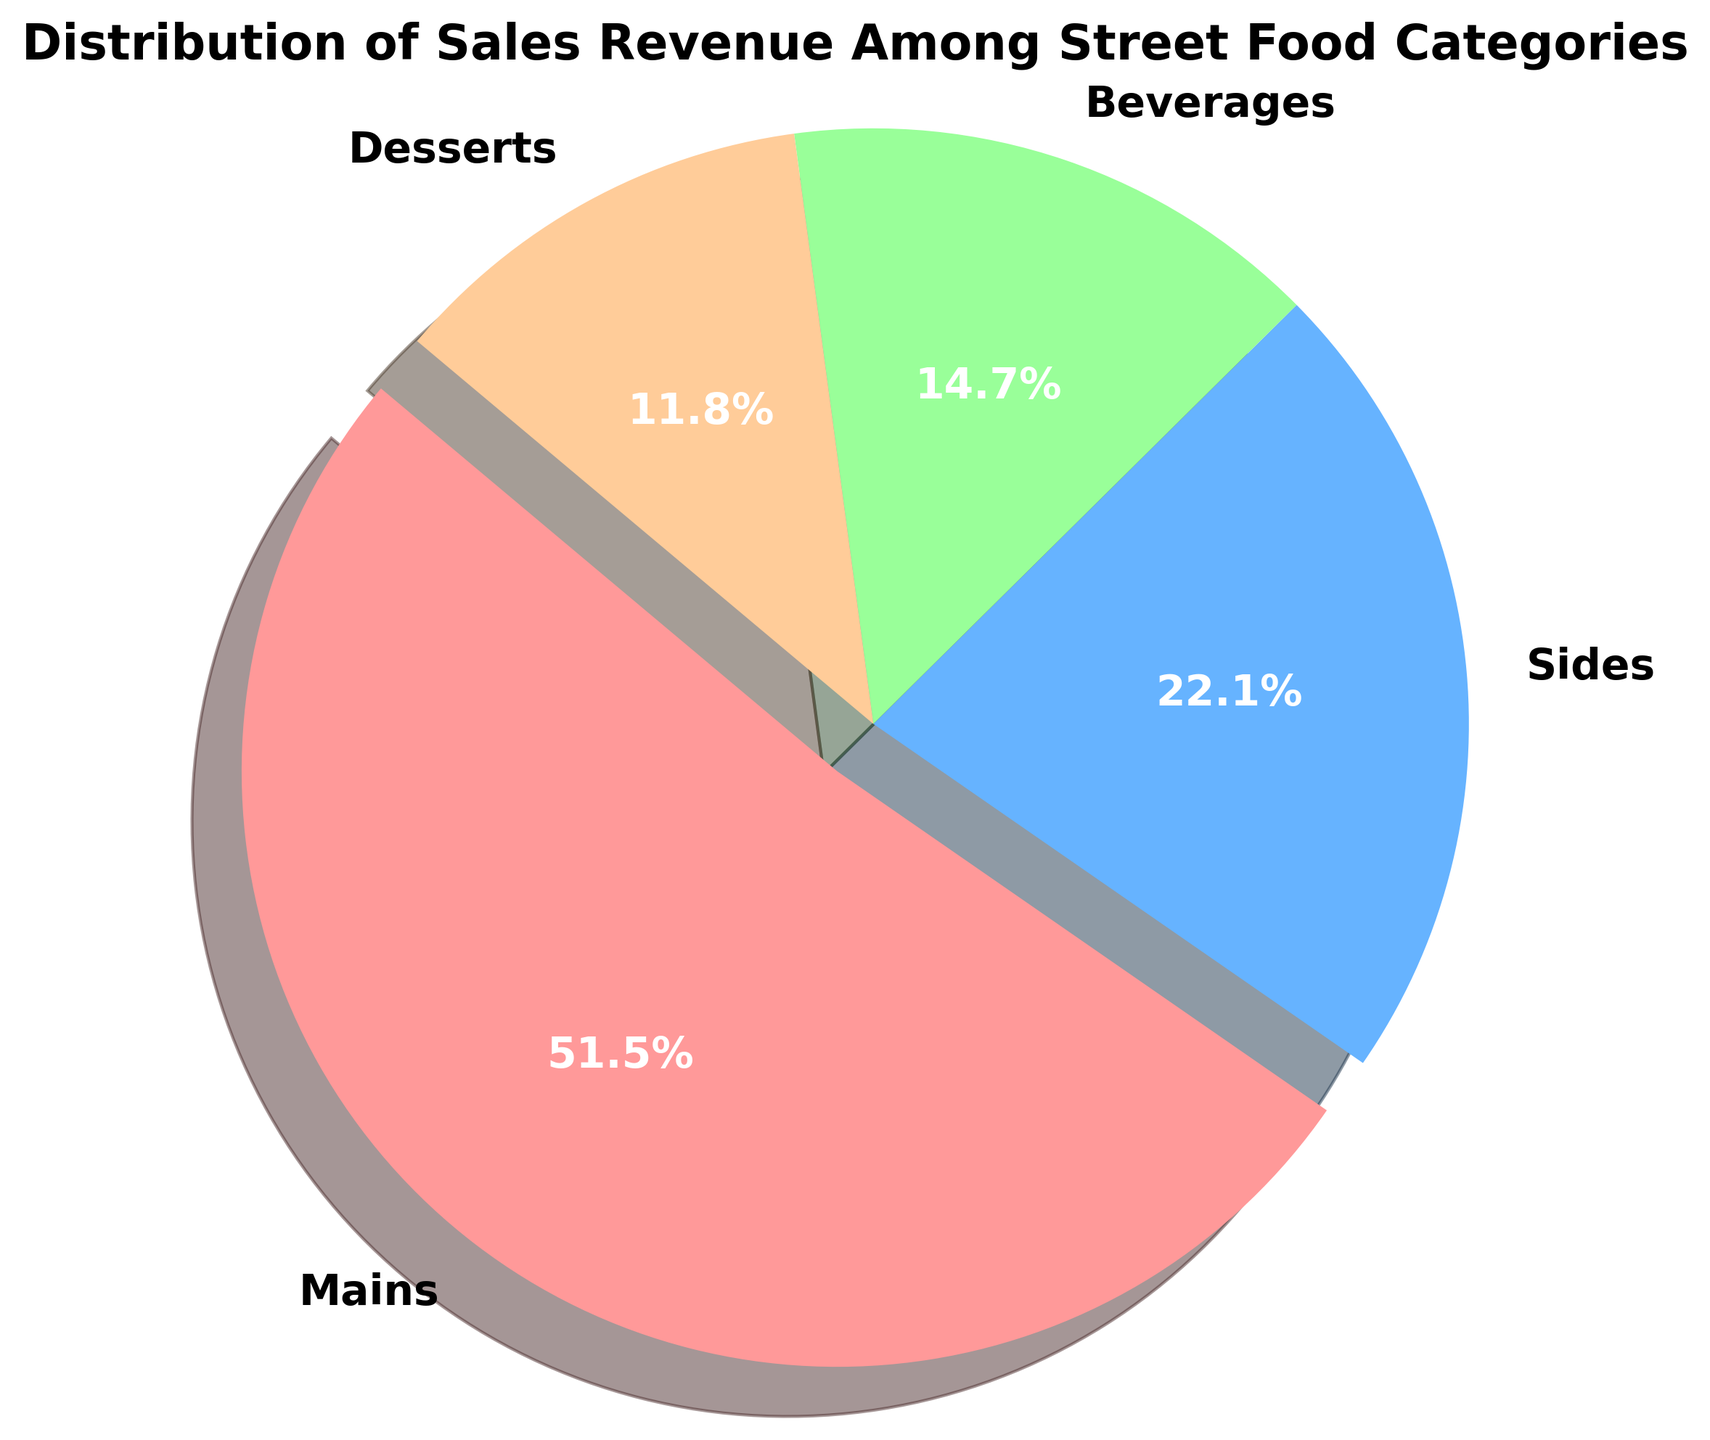Which category has the highest sales revenue? Look at the largest slice in the pie chart which is exploded to stand out, it represents the category "Mains" with 35,000 in revenue.
Answer: Mains What percentage of the total revenue does Beverages contribute? The pie chart shows percentage labels next to each category. Beverages contribute 12.9% as indicated on its slice.
Answer: 12.9% How much is the combined revenue from Sides and Desserts? Add the revenue values for Sides and Desserts from the chart labels, which are 15,000 and 8,000 respectively. 15,000 + 8,000 = 23,000.
Answer: 23,000 Which two categories together contribute less than half of the total revenue? Check the percentages of each category and add two of the lowest until their sum is less than 50%. Beverages (12.9%) + Desserts (10.3%) = 23.2%.
Answer: Beverages and Desserts What is the difference in revenue between Mains and Sides? Subtract the revenue of Sides from that of Mains. 35,000 - 15,000 = 20,000.
Answer: 20,000 How many categories contribute to more than a quarter of the total revenue individually? Only "Mains" with its 45.2% contribution is greater than 25% (a quarter).
Answer: 1 Is the category with the second-highest revenue more than double the revenue of the category with the lowest revenue? The second-highest revenue is for Sides (15,000) and the lowest is Desserts (8,000). Doubling 8,000 gives 16,000; since 15,000 is slightly less than 16,000, it is not more than double.
Answer: No What is the average revenue per category? Add all revenues (35,000 + 15,000 + 10,000 + 8,000) to get 68,000. Divide by the number of categories (4). 68,000 / 4 = 17,000.
Answer: 17,000 